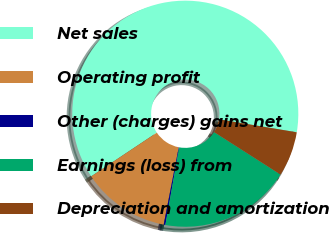Convert chart. <chart><loc_0><loc_0><loc_500><loc_500><pie_chart><fcel>Net sales<fcel>Operating profit<fcel>Other (charges) gains net<fcel>Earnings (loss) from<fcel>Depreciation and amortization<nl><fcel>61.99%<fcel>12.59%<fcel>0.24%<fcel>18.77%<fcel>6.42%<nl></chart> 